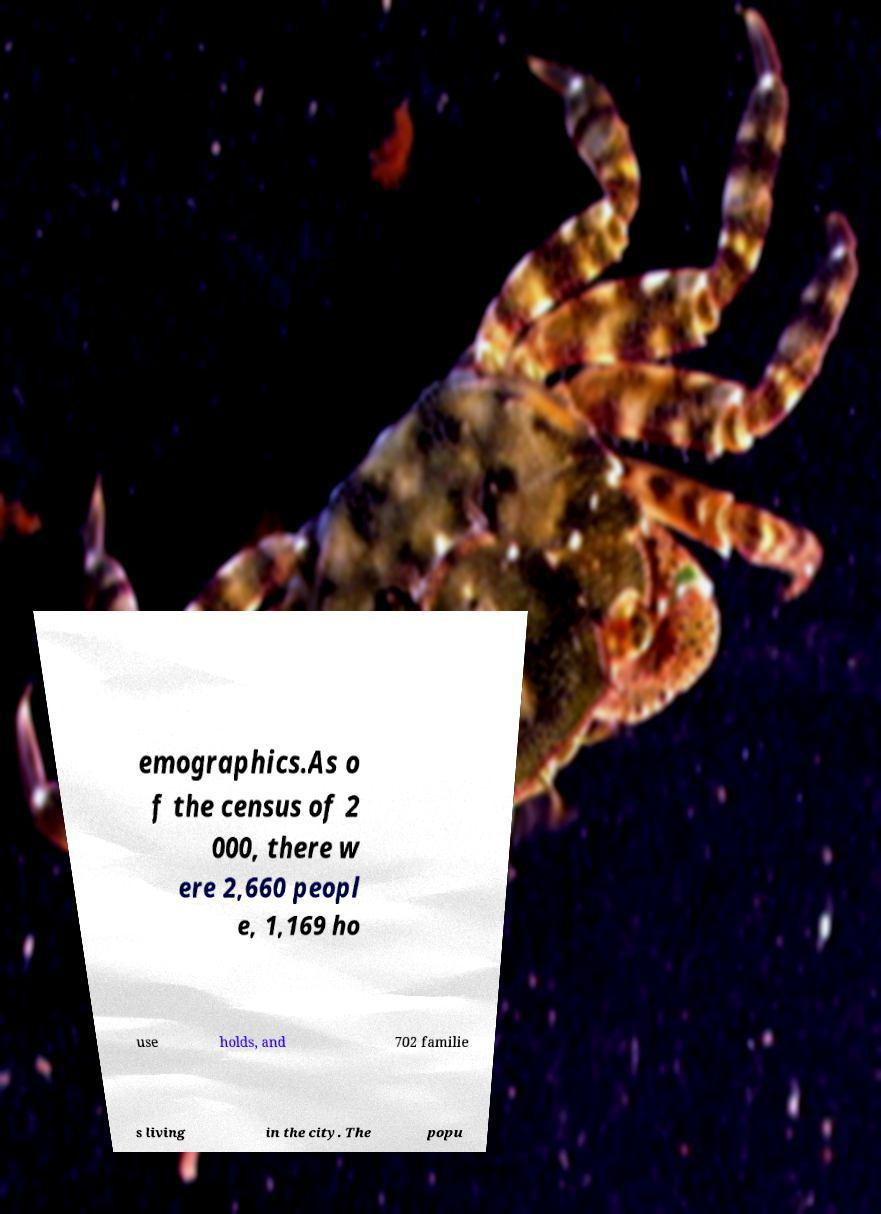Please read and relay the text visible in this image. What does it say? emographics.As o f the census of 2 000, there w ere 2,660 peopl e, 1,169 ho use holds, and 702 familie s living in the city. The popu 